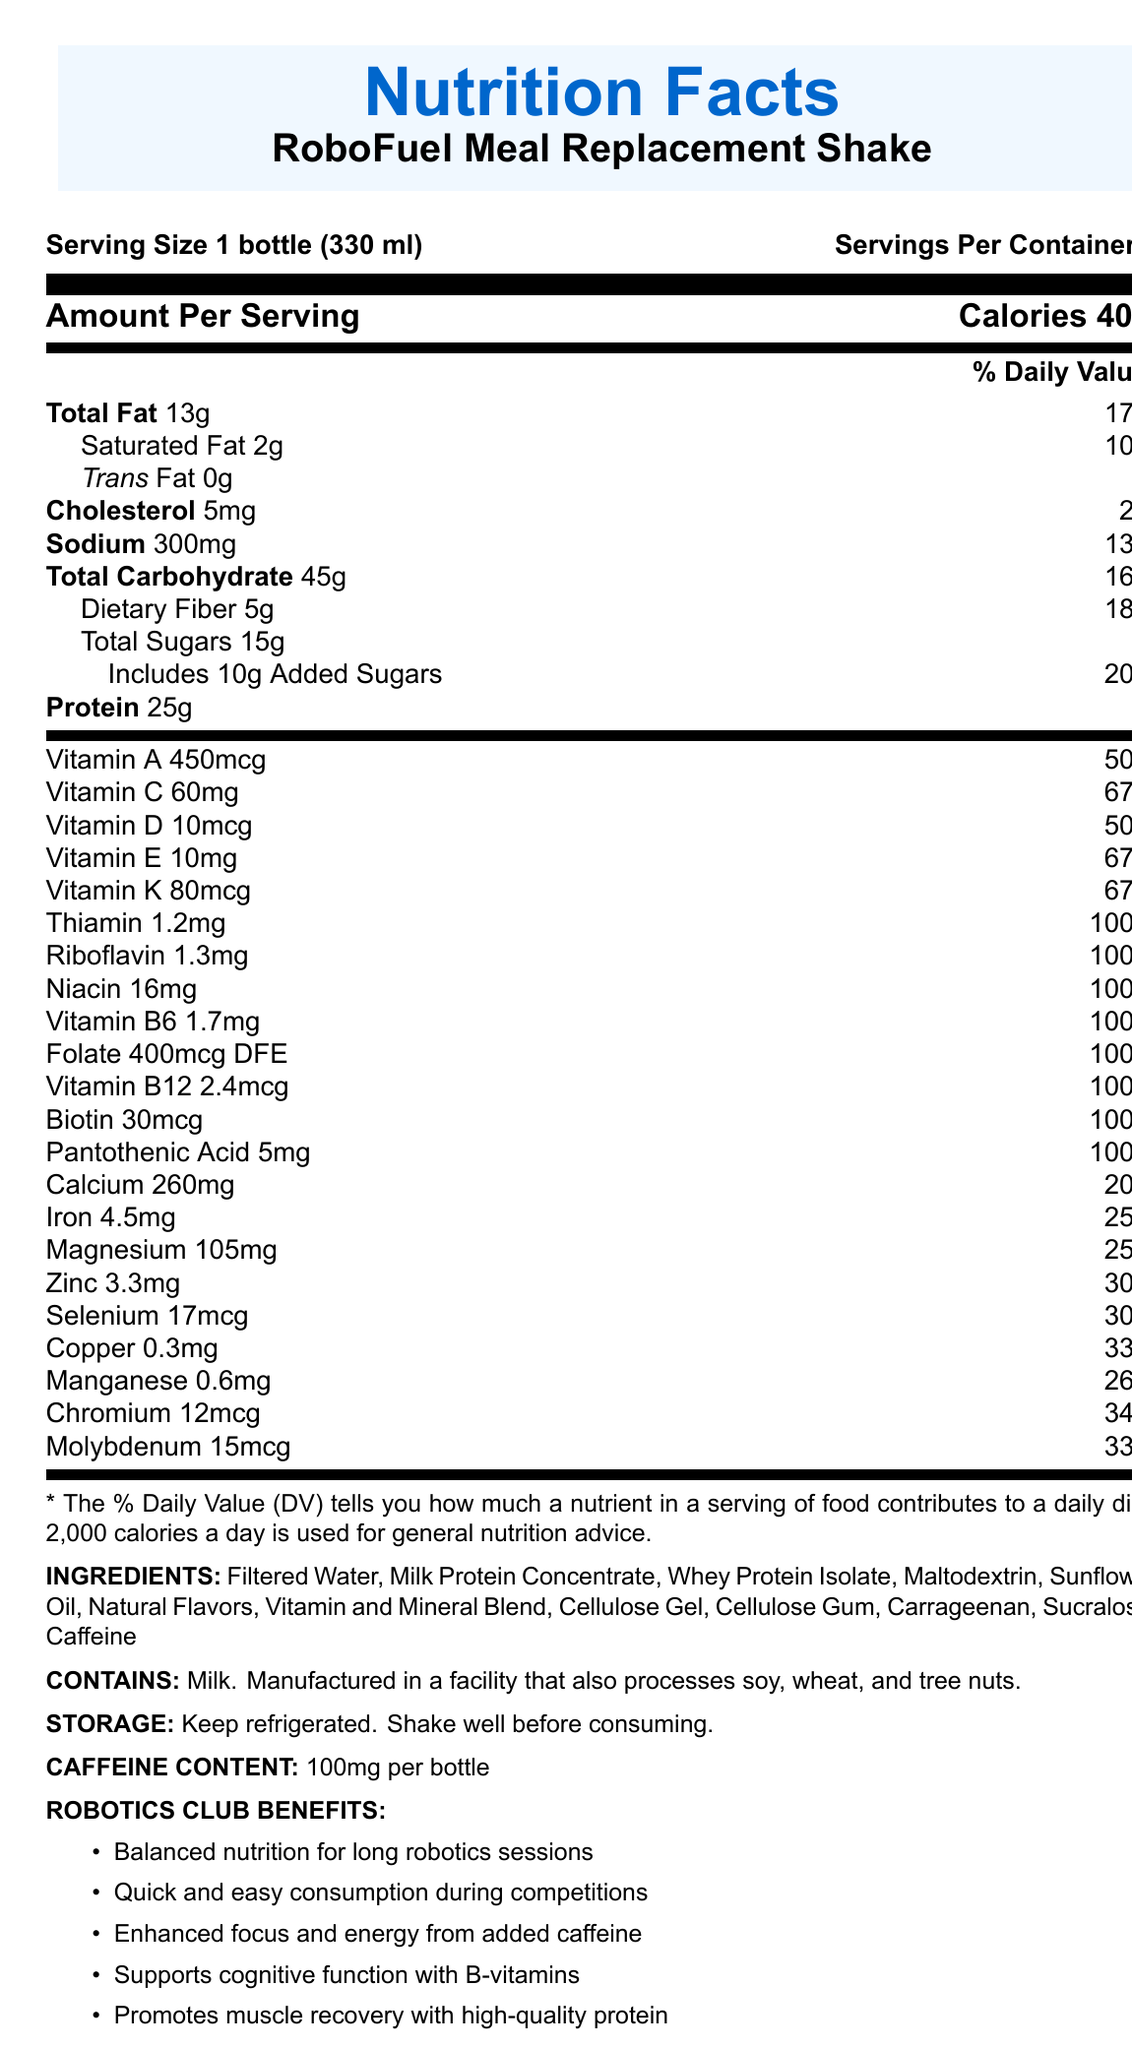what is the serving size of the RoboFuel Meal Replacement Shake? The document explicitly lists the serving size as "1 bottle (330 ml)".
Answer: 1 bottle (330 ml) how many calories are in one serving of the RoboFuel Meal Replacement Shake? The document states that there are 400 calories per serving.
Answer: 400 calories what is the daily value percentage of dietary fiber in the shake? The document mentions that the dietary fiber content is 5g, which is 18% of the daily value.
Answer: 18% which vitamin is present at 67% of the daily value? The document specifies that Vitamin C (60mg), Vitamin E (10mg), and Vitamin K (80mcg) each have a daily value of 67%.
Answer: Vitamin C, Vitamin E, and Vitamin K what is the main ingredient in the RoboFuel Meal Replacement Shake? The listed ingredients start with "Filtered Water."
Answer: Filtered Water which of the following are benefits of the RoboFuel Meal Replacement Shake? A. Quick and easy consumption during competitions B. Supports bone strength C. Enhanced focus and energy from added caffeine D. Balanced nutrition for long robotics sessions E. Promotes muscle recovery According to the document, the benefits include Quick and easy consumption during competitions, Enhanced focus and energy from added caffeine, Balanced nutrition for long robotics sessions, and Promotes muscle recovery.
Answer: A, C, D, E what types of fat does the RoboFuel Meal Replacement Shake contain? The document states the shake contains Saturated Fat (2g) and 0g Trans Fat.
Answer: Saturated Fat, Trans Fat is the RoboFuel Meal Replacement Shake suitable for people with milk allergies? The allergen information clearly states that it contains milk.
Answer: No how much caffeine does the RoboFuel Meal Replacement Shake contain per serving? The document states the caffeine content as 100mg per bottle.
Answer: 100mg which of these vitamins have a daily value of 100% in the shake? I. Vitamin B6 II. Thiamin III. Vitamin D IV. Folate Vitamin B6 (1.7mg), Thiamin (1.2mg), and Folate (400mcg DFE) each have a 100% daily value.
Answer: I, II, IV describe the main purpose and nutritional focus of the RoboFuel Meal Replacement Shake document. It outlines the serving size, calories, various nutrient amounts with their daily values, ingredients, allergen information, and specific benefits for robotics club members.
Answer: The document provides detailed nutritional information about the RoboFuel Meal Replacement Shake, emphasizing its balanced nutritional content, high protein, vitamins, and minerals, as well as its specific benefits for busy robotics club members, including cognitive support and convenience during competitions. what is the percentage daily value of iron in the shake? The document lists iron as containing 4.5mg, which is 25% of the daily value.
Answer: 25% what is the storage instruction provided for the shake? The storage instructions specify to keep it refrigerated and to shake well before consuming.
Answer: Keep refrigerated. Shake well before consuming. what is the address of the manufacturer of the RoboFuel Meal Replacement Shake? The manufacturer's address is provided as RoboFuel Nutrition, Inc., 123 Tech Drive, Silicon Valley, CA 94000.
Answer: 123 Tech Drive, Silicon Valley, CA 94000 can I get detailed information about the production process of the RoboFuel Meal Replacement Shake from the document? The document provides nutritional details and benefits but does not include information about the production process.
Answer: Cannot be determined 